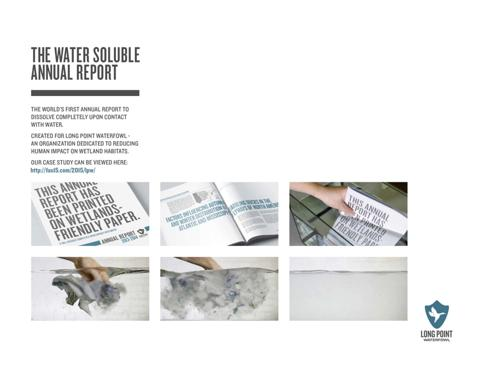How can the case study be accessed? The case study associated with Long Point Waterfowl’s annual report can be accessed by visiting the URL provided in the image. The link, clearly highlighted, reads 'our case study can be viewed here,' guiding viewers directly to further in-depth information about their initiatives and findings. 